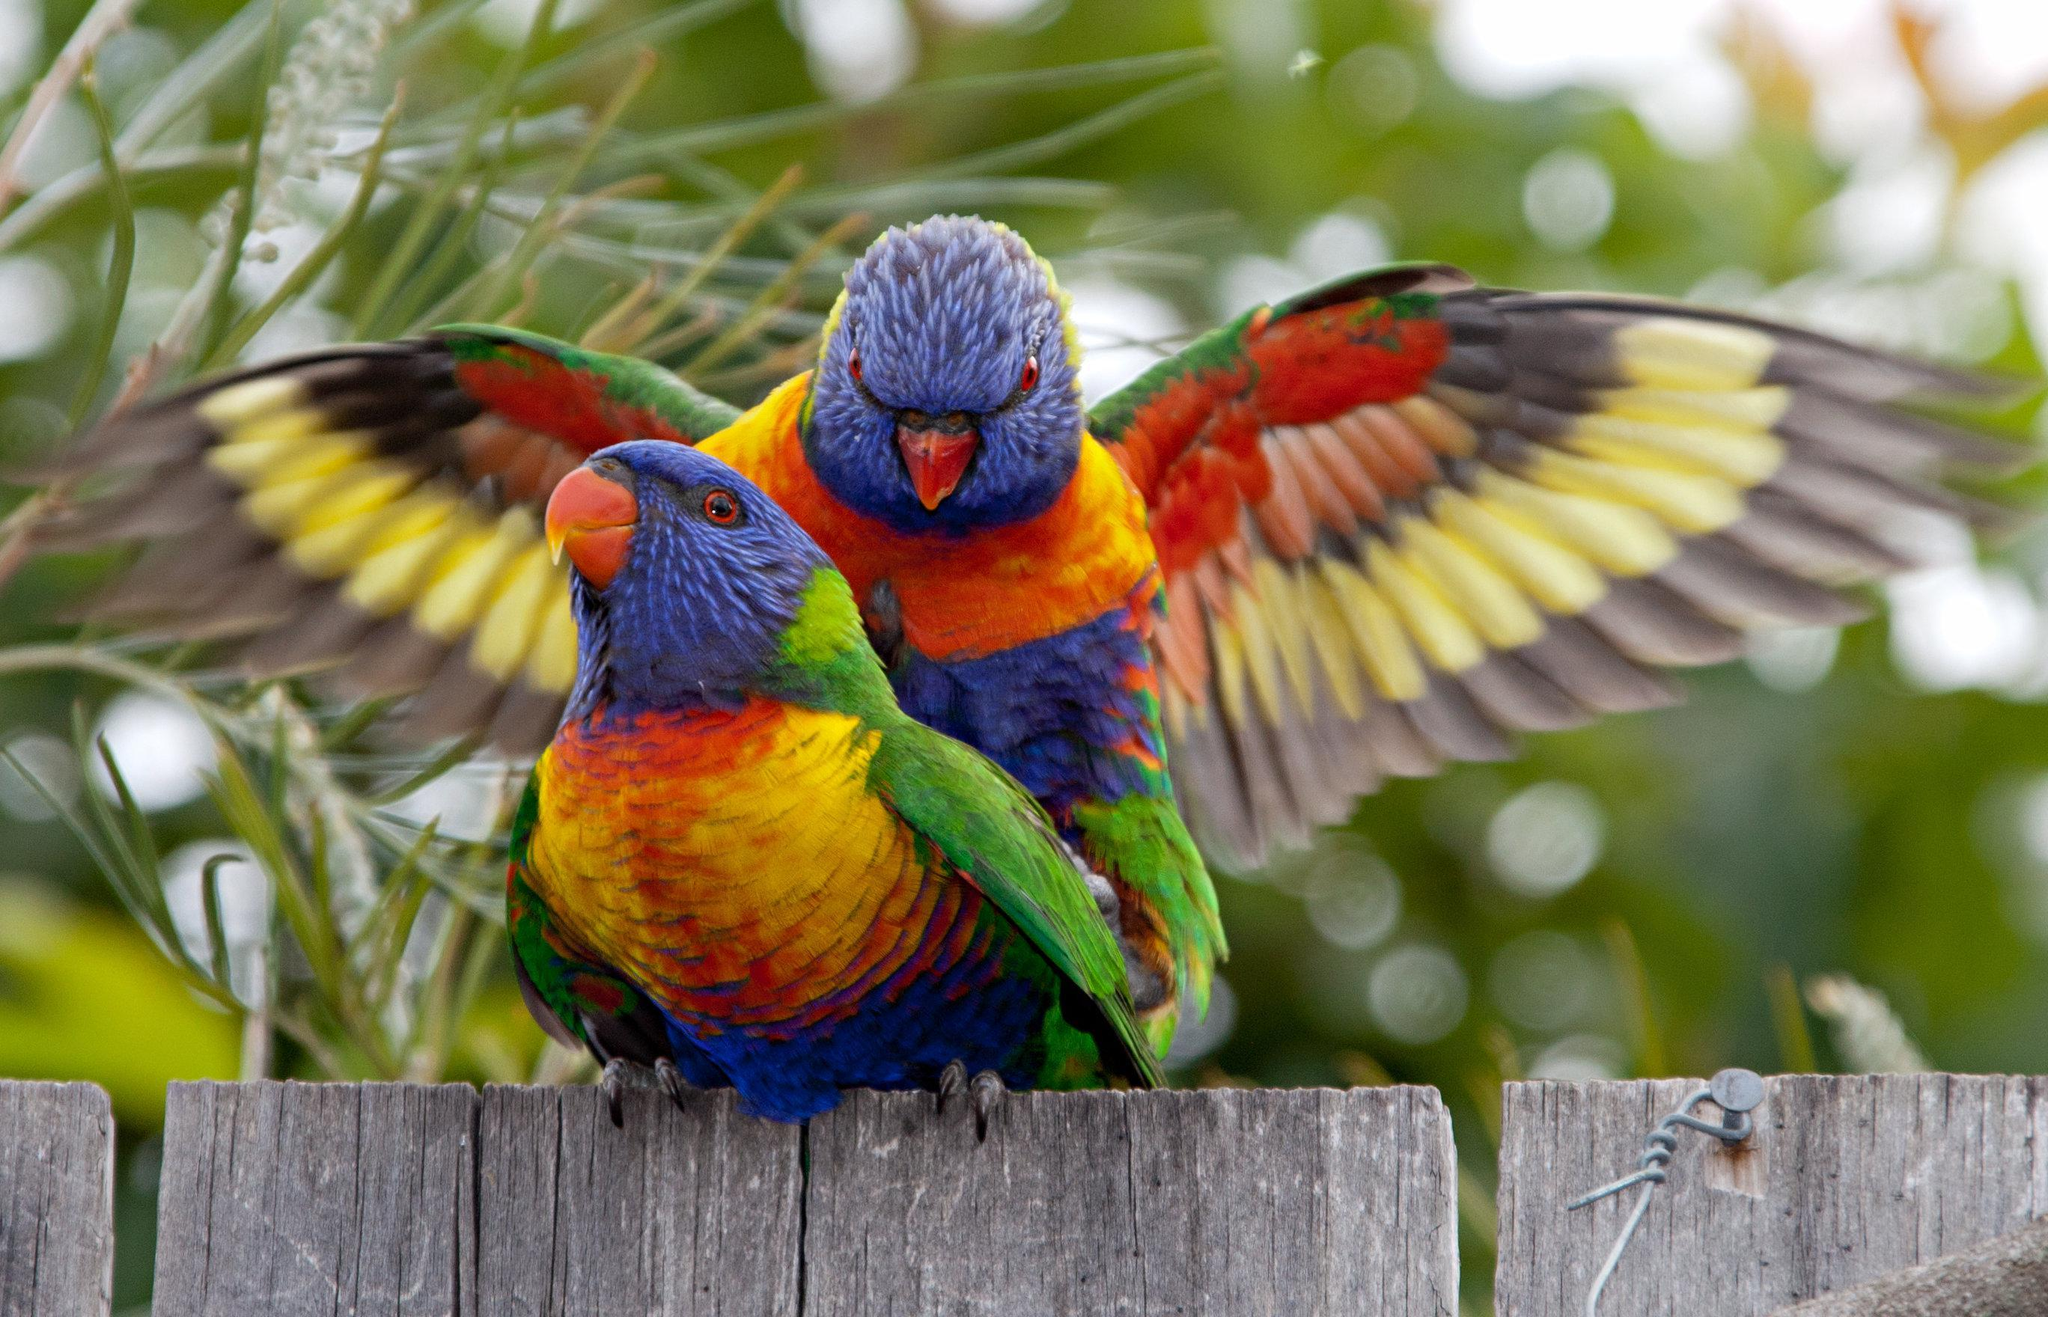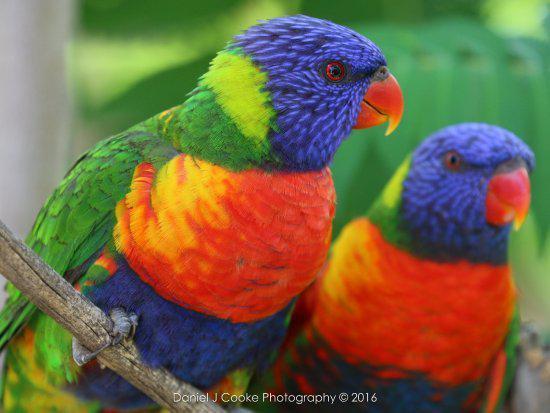The first image is the image on the left, the second image is the image on the right. Examine the images to the left and right. Is the description "In at least one image a single visually perched bird with blue and green feather is facing right." accurate? Answer yes or no. No. The first image is the image on the left, the second image is the image on the right. For the images displayed, is the sentence "Every bird has a head that is more than half blue." factually correct? Answer yes or no. Yes. 